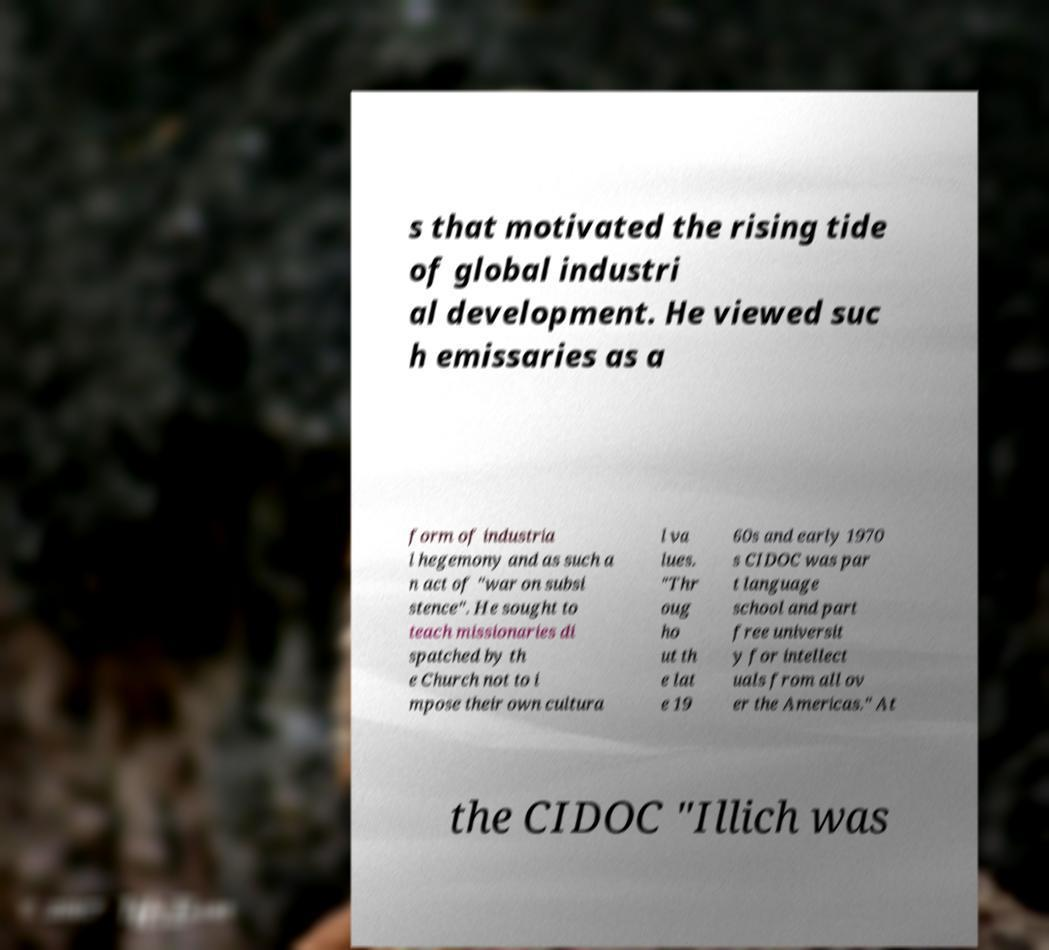There's text embedded in this image that I need extracted. Can you transcribe it verbatim? s that motivated the rising tide of global industri al development. He viewed suc h emissaries as a form of industria l hegemony and as such a n act of "war on subsi stence". He sought to teach missionaries di spatched by th e Church not to i mpose their own cultura l va lues. "Thr oug ho ut th e lat e 19 60s and early 1970 s CIDOC was par t language school and part free universit y for intellect uals from all ov er the Americas." At the CIDOC "Illich was 